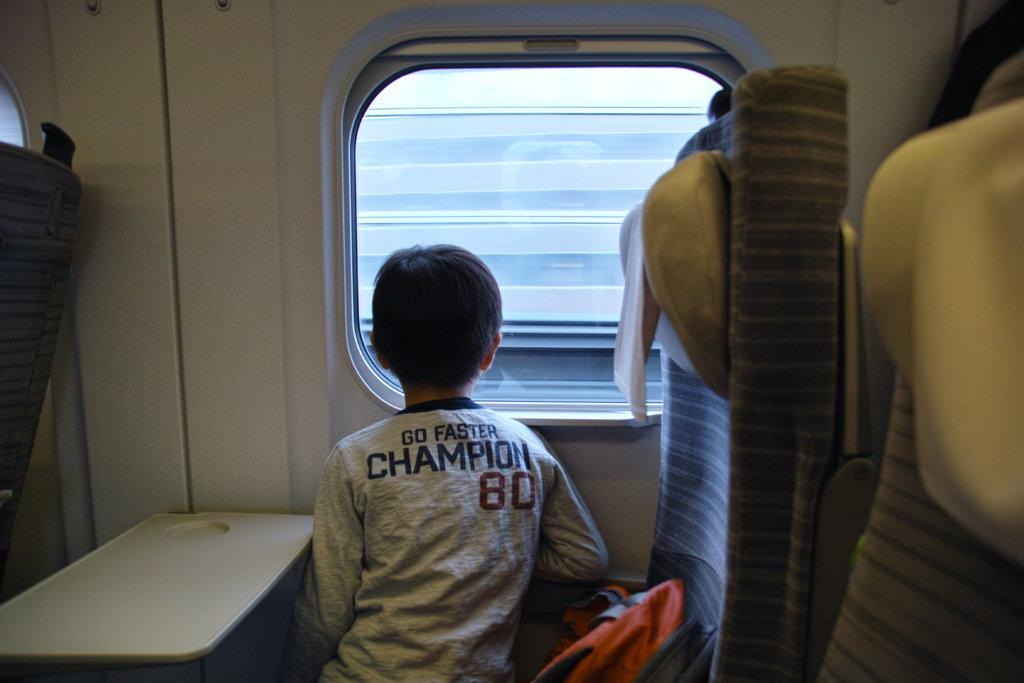What type of location is depicted in the image? The image is an inside view of a train. What can be seen inside the train? There is a boy sitting on a seat in the image, and there is a white table in front of him. What is the purpose of the glass window beside the boy? The glass window beside the boy provides a view of the outside while he is on the train. How does the jelly contribute to the train's speed in the image? There is no jelly present in the image, so it cannot contribute to the train's speed. 